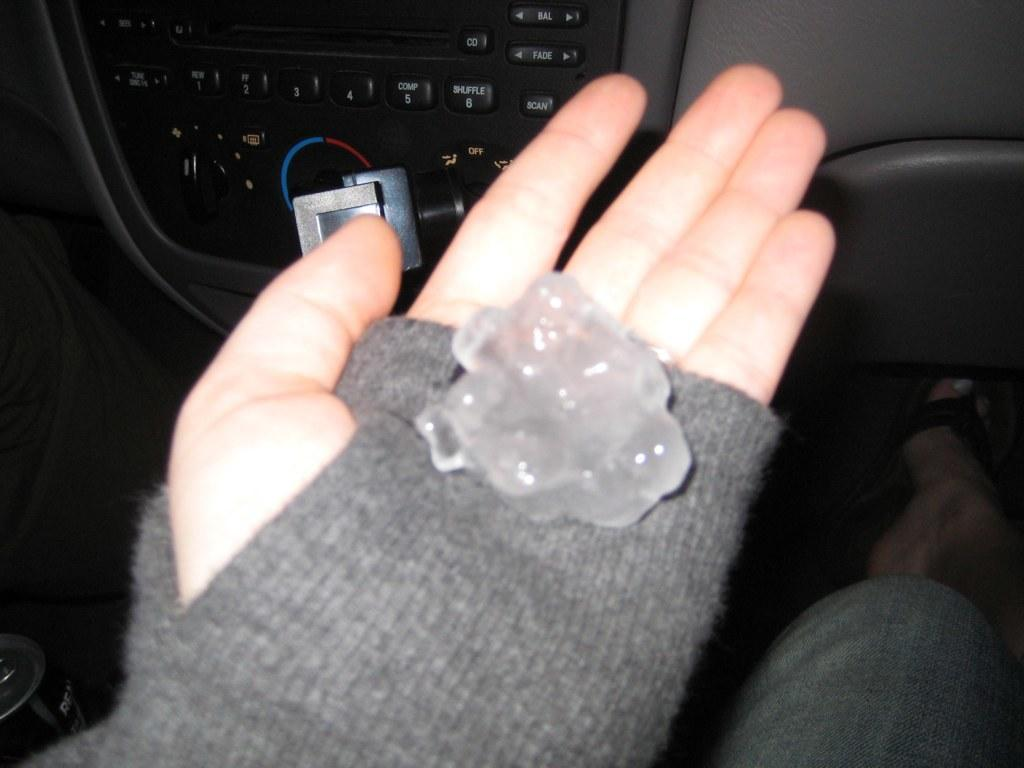What type of setting is depicted in the image? The image shows an inside view of a vehicle. What can be seen inside the vehicle? There is a tin and a person's hand holding an object visible in the image. What are the buttons at the top of the image used for? The buttons at the top of the image are likely used for controlling various vehicle functions. How many spiders are crawling on the tin in the image? There are no spiders visible in the image; it only shows a tin and a person's hand holding an object. What type of stamp is being used by the person in the image? There is no stamp present in the image; it only shows a tin and a person's hand holding an object. 